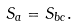<formula> <loc_0><loc_0><loc_500><loc_500>S _ { a } = S _ { b c } .</formula> 